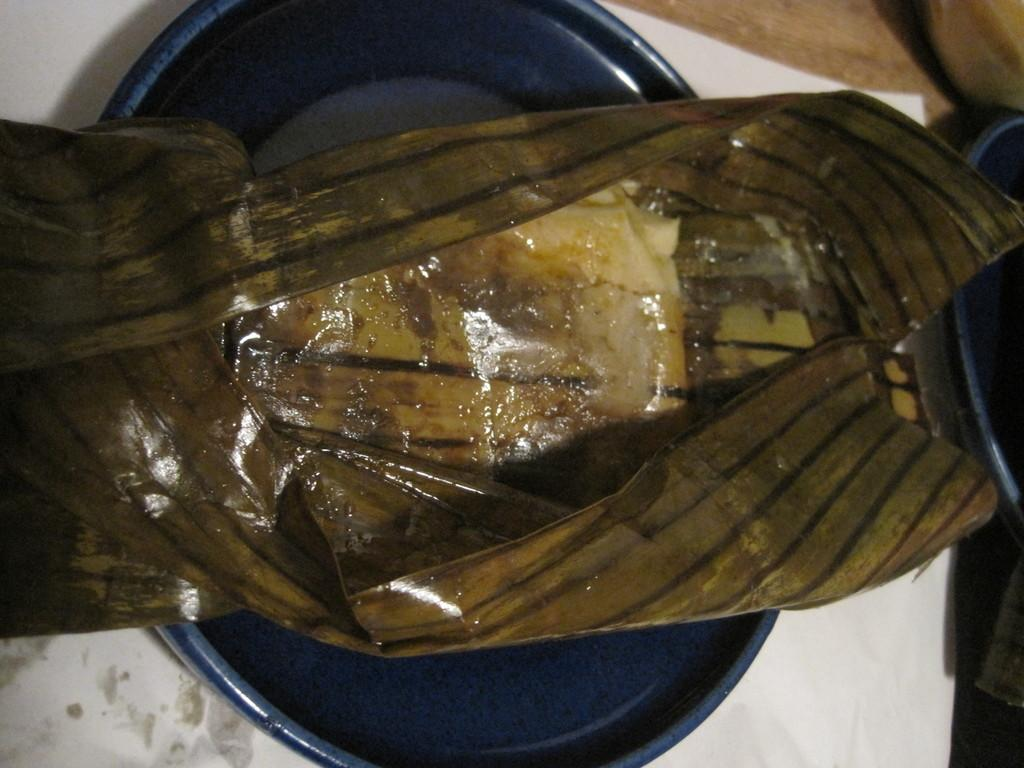What is the color of the plastic cover in the image? The plastic cover in the image is brown. What is the color of the bowl in the image? The bowl in the image is blue. What is the bowl placed on in the image? The blue color bowl is placed on a white color paper. Where is the white color paper located in the image? The white color paper is on the floor. How does the wren interact with the brown plastic cover in the image? There is no wren present in the image, so it cannot interact with the brown plastic cover. 